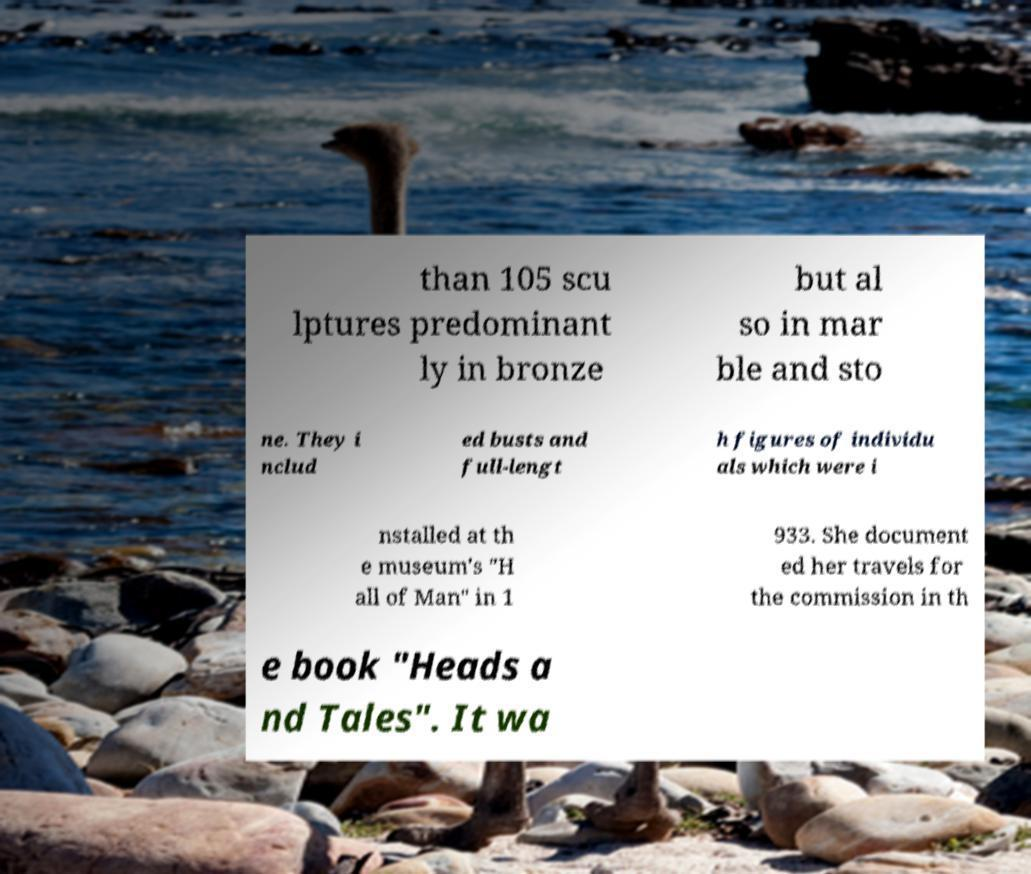Can you accurately transcribe the text from the provided image for me? than 105 scu lptures predominant ly in bronze but al so in mar ble and sto ne. They i nclud ed busts and full-lengt h figures of individu als which were i nstalled at th e museum's "H all of Man" in 1 933. She document ed her travels for the commission in th e book "Heads a nd Tales". It wa 